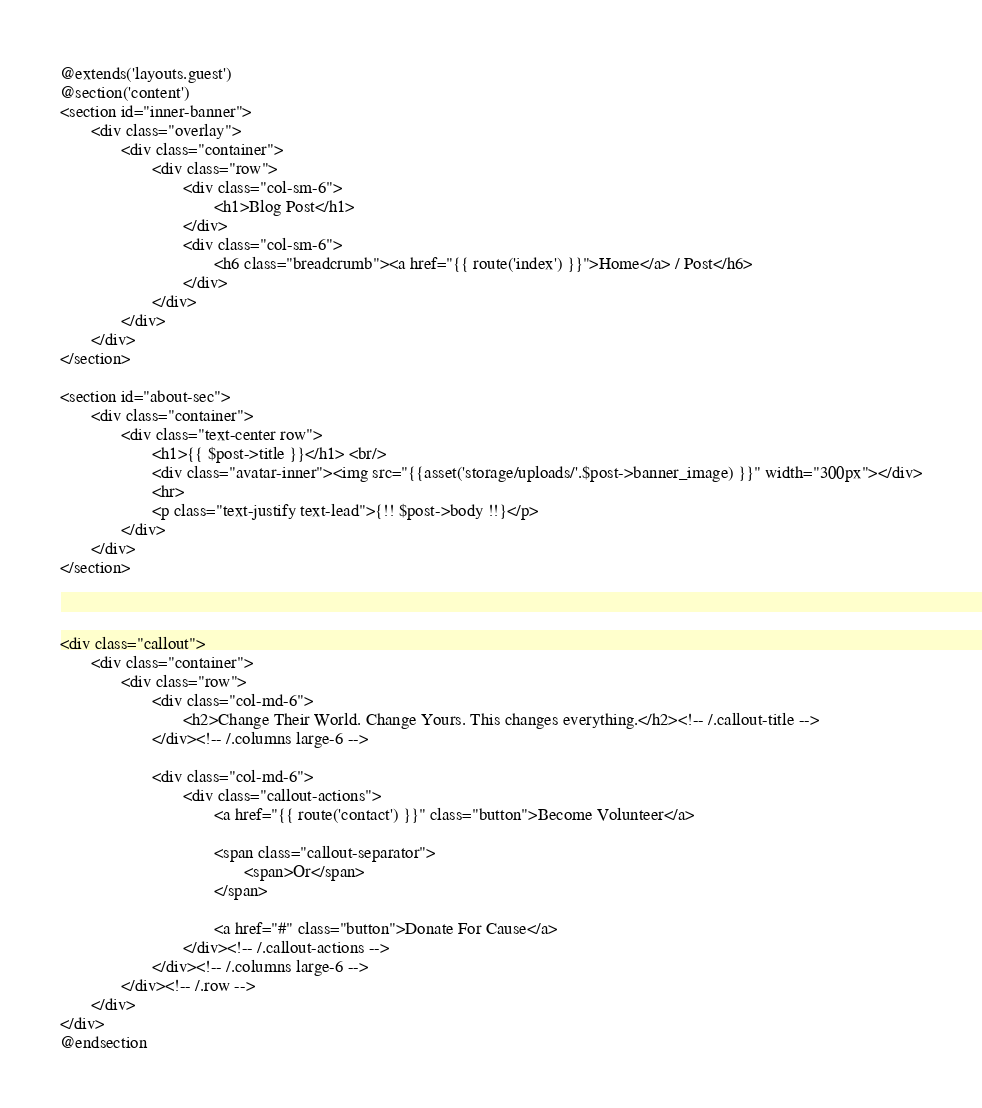<code> <loc_0><loc_0><loc_500><loc_500><_PHP_>@extends('layouts.guest')
@section('content')
<section id="inner-banner">
       <div class="overlay">
              <div class="container">
                     <div class="row">
                            <div class="col-sm-6">
                                   <h1>Blog Post</h1>
                            </div>
                            <div class="col-sm-6">
                                   <h6 class="breadcrumb"><a href="{{ route('index') }}">Home</a> / Post</h6>
                            </div>
                     </div>
              </div>
       </div>
</section>

<section id="about-sec">
       <div class="container">
              <div class="text-center row">
                     <h1>{{ $post->title }}</h1> <br/>
                     <div class="avatar-inner"><img src="{{asset('storage/uploads/'.$post->banner_image) }}" width="300px"></div>
                     <hr>
                     <p class="text-justify text-lead">{!! $post->body !!}</p>
              </div>
       </div>
</section>



<div class="callout">
       <div class="container">
              <div class="row">
                     <div class="col-md-6">
                            <h2>Change Their World. Change Yours. This changes everything.</h2><!-- /.callout-title -->
                     </div><!-- /.columns large-6 -->

                     <div class="col-md-6">
                            <div class="callout-actions">
                                   <a href="{{ route('contact') }}" class="button">Become Volunteer</a>

                                   <span class="callout-separator">
                                          <span>Or</span>
                                   </span>

                                   <a href="#" class="button">Donate For Cause</a>
                            </div><!-- /.callout-actions -->
                     </div><!-- /.columns large-6 -->
              </div><!-- /.row -->
       </div>
</div>
@endsection

</code> 